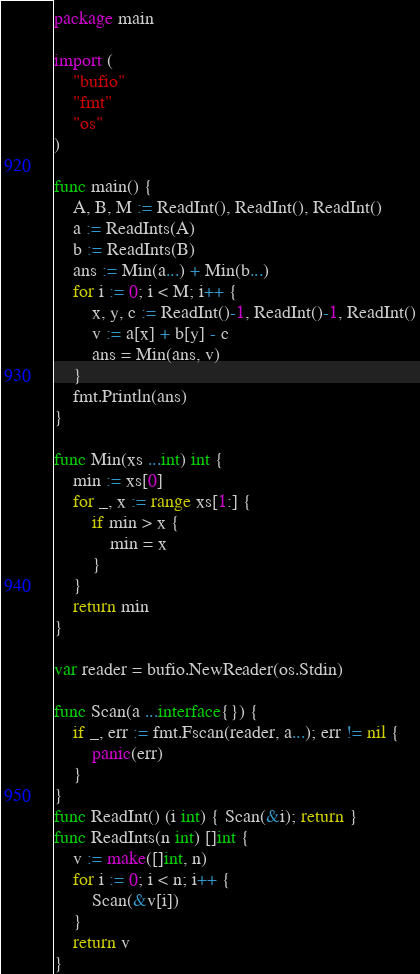Convert code to text. <code><loc_0><loc_0><loc_500><loc_500><_Go_>package main

import (
	"bufio"
	"fmt"
	"os"
)

func main() {
	A, B, M := ReadInt(), ReadInt(), ReadInt()
	a := ReadInts(A)
	b := ReadInts(B)
	ans := Min(a...) + Min(b...)
	for i := 0; i < M; i++ {
		x, y, c := ReadInt()-1, ReadInt()-1, ReadInt()
		v := a[x] + b[y] - c
		ans = Min(ans, v)
	}
	fmt.Println(ans)
}

func Min(xs ...int) int {
	min := xs[0]
	for _, x := range xs[1:] {
		if min > x {
			min = x
		}
	}
	return min
}

var reader = bufio.NewReader(os.Stdin)

func Scan(a ...interface{}) {
	if _, err := fmt.Fscan(reader, a...); err != nil {
		panic(err)
	}
}
func ReadInt() (i int) { Scan(&i); return }
func ReadInts(n int) []int {
	v := make([]int, n)
	for i := 0; i < n; i++ {
		Scan(&v[i])
	}
	return v
}
</code> 